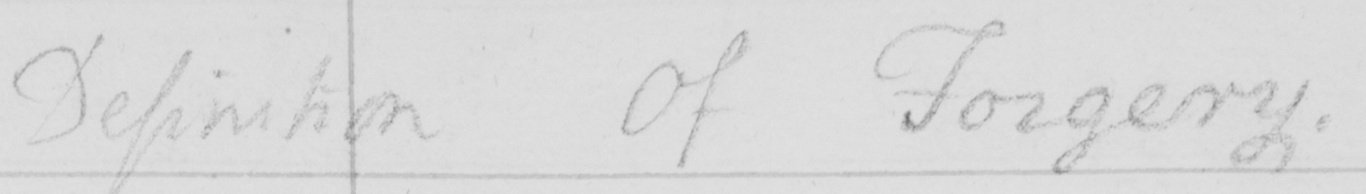Please transcribe the handwritten text in this image. Definition Of Forgery . 